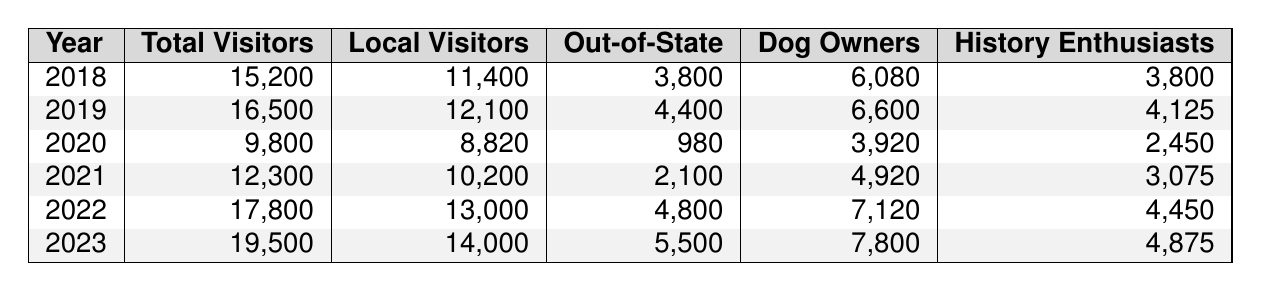What was the total number of visitors to the Horse Trough Fountain in 2022? According to the table, the total number of visitors in 2022 is presented in the second column next to the year 2022. The value is 17,800.
Answer: 17,800 How many local visitors were there in 2021? The number of local visitors for the year 2021 can be found in the third column corresponding to that year. The value listed is 10,200.
Answer: 10,200 What is the difference in total visitors between 2020 and 2023? To find this difference, subtract the total visitors in 2020 (9,800) from the total visitors in 2023 (19,500). The calculation is 19,500 - 9,800 = 9,700.
Answer: 9,700 How many out-of-state visitors were there in 2019? The number of out-of-state visitors for 2019 is found in the fourth column next to the year 2019. The value is 4,400.
Answer: 4,400 What is the average number of dog owners from 2018 to 2022? First, sum the number of dog owners from each year: 6,080 + 6,600 + 3,920 + 4,920 + 7,120 = 28,640. There are 5 years, so the average is 28,640 / 5 = 5,728.
Answer: 5,728 Are there more history enthusiasts in 2023 than in 2020? In 2023, the number of history enthusiasts is 4,875, while in 2020 it is 2,450. Since 4,875 is greater than 2,450, the answer is yes.
Answer: Yes What year had the highest number of local visitors? By examining the local visitors column, the highest number is found in 2023 with 14,000.
Answer: 2023 What was the percentage increase in total visitors from 2018 to 2022? First, find the difference: 17,800 (2022) - 15,200 (2018) = 2,600. Then, divide by the number of visitors in 2018: 2,600 / 15,200. To get the percentage, multiply by 100: (2,600 / 15,200) * 100 = 17.1%.
Answer: 17.1% In which year was the number of dog owners the least? The column for dog owners indicates the smallest value is in 2020 with 3,920.
Answer: 2020 What was the total number of out-of-state visitors from 2018 to 2023? The out-of-state visitors from each year are: 3,800 (2018) + 4,400 (2019) + 980 (2020) + 2,100 (2021) + 4,800 (2022) + 5,500 (2023) = 21,580.
Answer: 21,580 